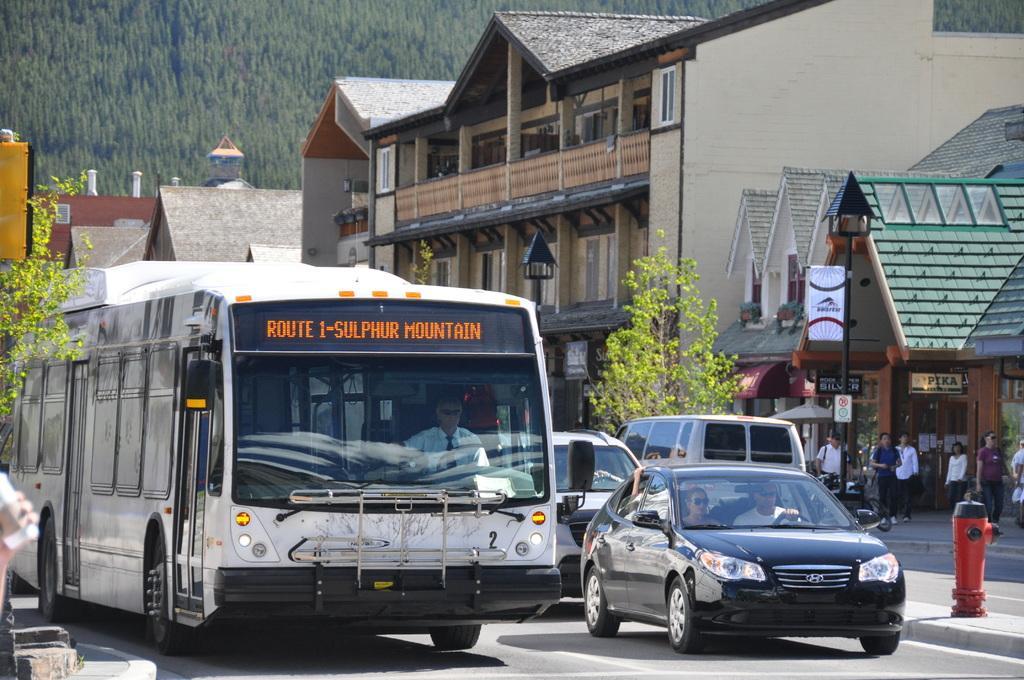How would you summarize this image in a sentence or two? In the image there are vehicles on the road, beside the road there are few people, some stores and buildings. In the background there are many trees. 